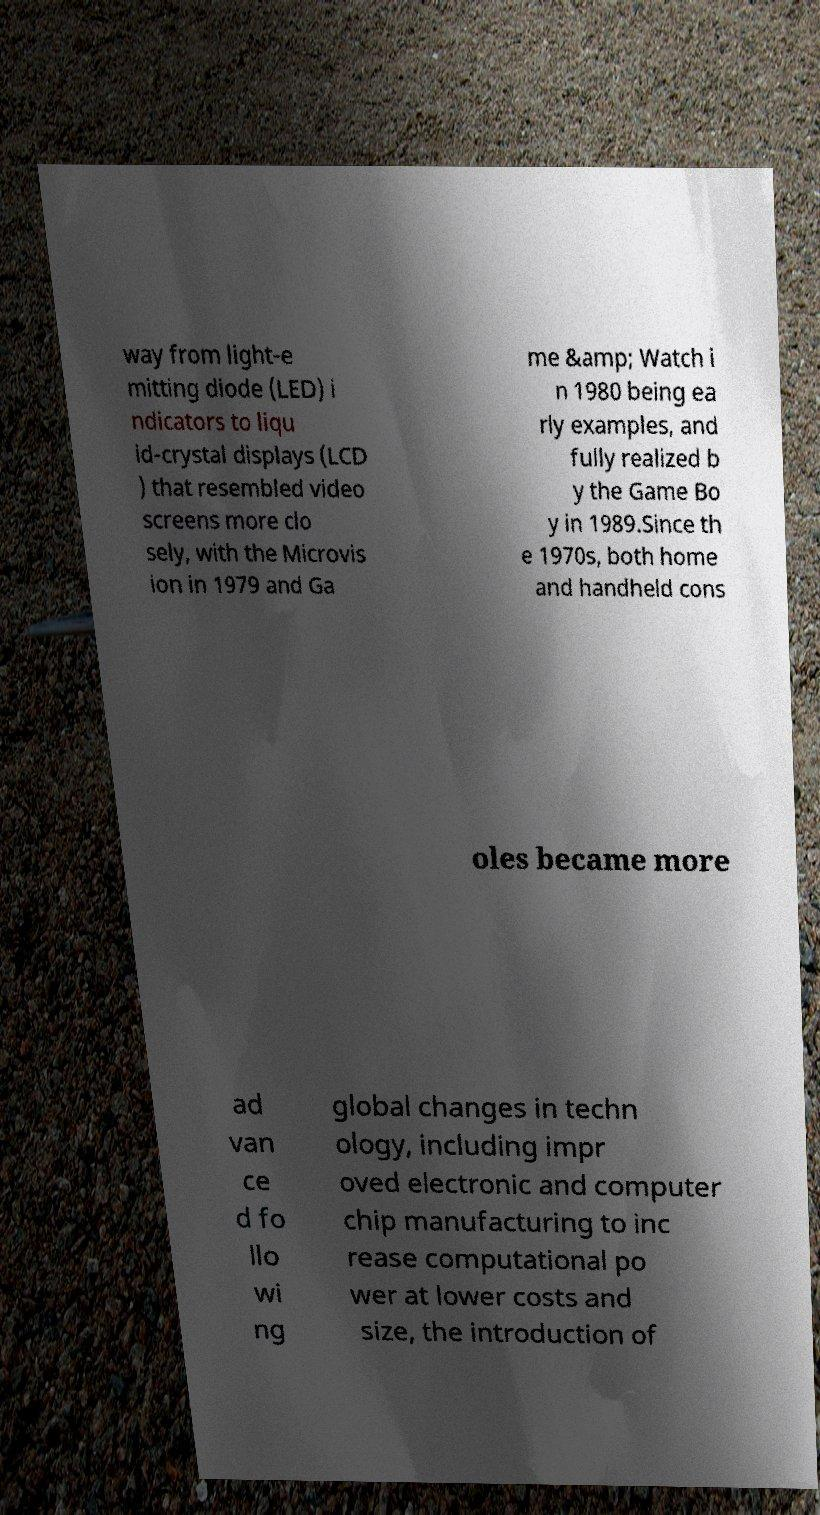There's text embedded in this image that I need extracted. Can you transcribe it verbatim? way from light-e mitting diode (LED) i ndicators to liqu id-crystal displays (LCD ) that resembled video screens more clo sely, with the Microvis ion in 1979 and Ga me &amp; Watch i n 1980 being ea rly examples, and fully realized b y the Game Bo y in 1989.Since th e 1970s, both home and handheld cons oles became more ad van ce d fo llo wi ng global changes in techn ology, including impr oved electronic and computer chip manufacturing to inc rease computational po wer at lower costs and size, the introduction of 